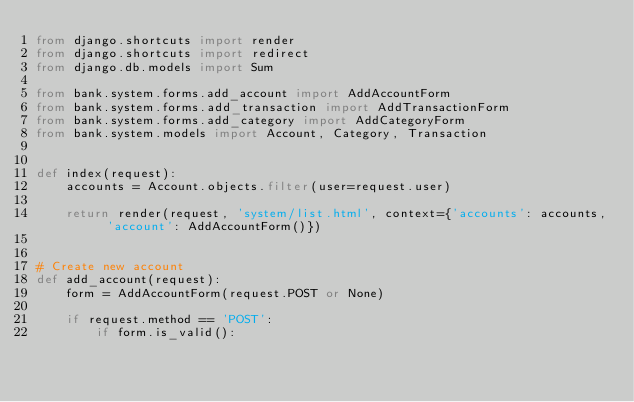<code> <loc_0><loc_0><loc_500><loc_500><_Python_>from django.shortcuts import render
from django.shortcuts import redirect
from django.db.models import Sum

from bank.system.forms.add_account import AddAccountForm
from bank.system.forms.add_transaction import AddTransactionForm
from bank.system.forms.add_category import AddCategoryForm
from bank.system.models import Account, Category, Transaction


def index(request):
    accounts = Account.objects.filter(user=request.user)

    return render(request, 'system/list.html', context={'accounts': accounts, 'account': AddAccountForm()})


# Create new account
def add_account(request):
    form = AddAccountForm(request.POST or None)

    if request.method == 'POST':
        if form.is_valid():</code> 